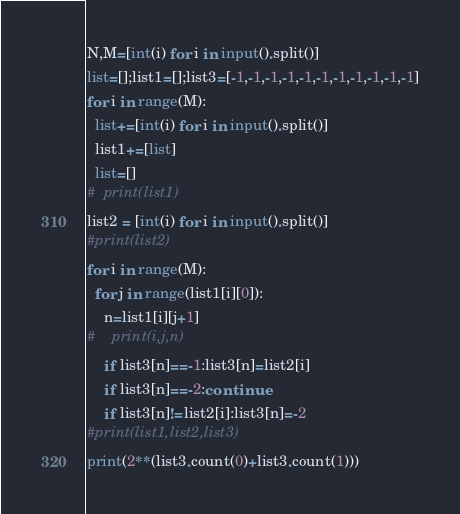Convert code to text. <code><loc_0><loc_0><loc_500><loc_500><_Python_>N,M=[int(i) for i in input().split()]
list=[];list1=[];list3=[-1,-1,-1,-1,-1,-1,-1,-1,-1,-1,-1]
for i in range(M):
  list+=[int(i) for i in input().split()]
  list1+=[list]
  list=[]
#  print(list1)
list2 = [int(i) for i in input().split()]
#print(list2)
for i in range(M):
  for j in range(list1[i][0]):
    n=list1[i][j+1]
#    print(i,j,n)
    if list3[n]==-1:list3[n]=list2[i]
    if list3[n]==-2:continue
    if list3[n]!=list2[i]:list3[n]=-2
#print(list1,list2,list3)
print(2**(list3.count(0)+list3.count(1)))</code> 